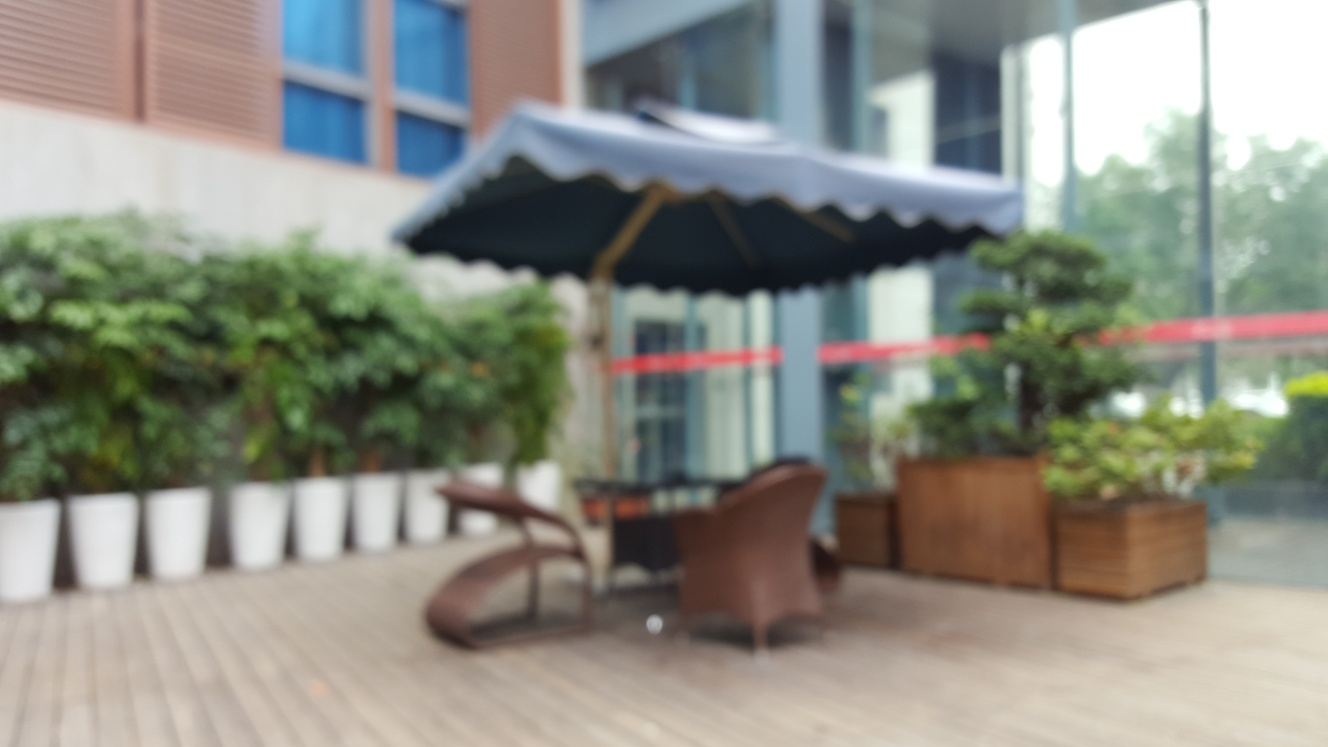Can you comment on the weather condition depicted in the image? Despite the blur, the image does not show signs of rain or adverse weather. The presence of an open umbrella could suggest a sunny day designed to provide shade for comfort, or it simply could be a fixture of the seating area's design, intended for use as needed. 